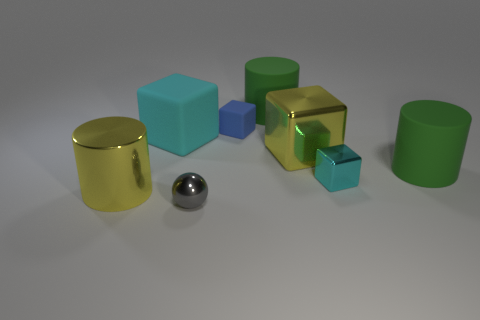What is the shape of the metal thing that is left of the tiny blue object and to the right of the large cyan block? The metal object situated to the left of the tiny blue cube and to the right of the larger cyan block has a spherical shape, exhibiting a smooth and shiny surface that reflects its surroundings. 